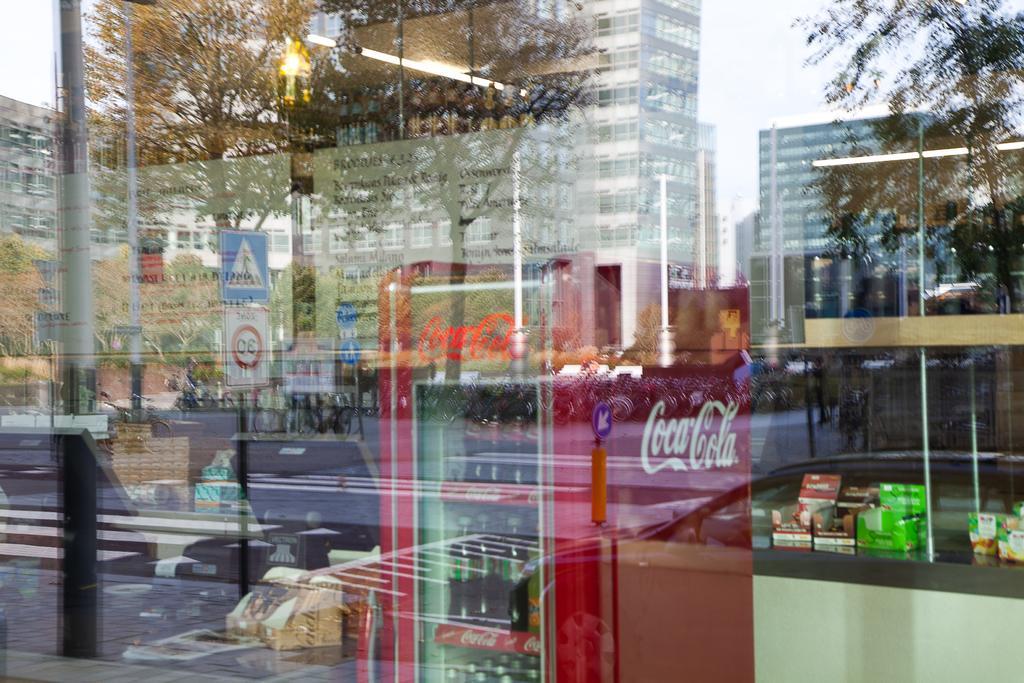Can you describe this image briefly? In this picture we can see a glass in the front, from the glass we can see a refrigerator, we can see reflection of buildings, poles, trees, boards and the sky on this glass, we can also see a light from the glass. 